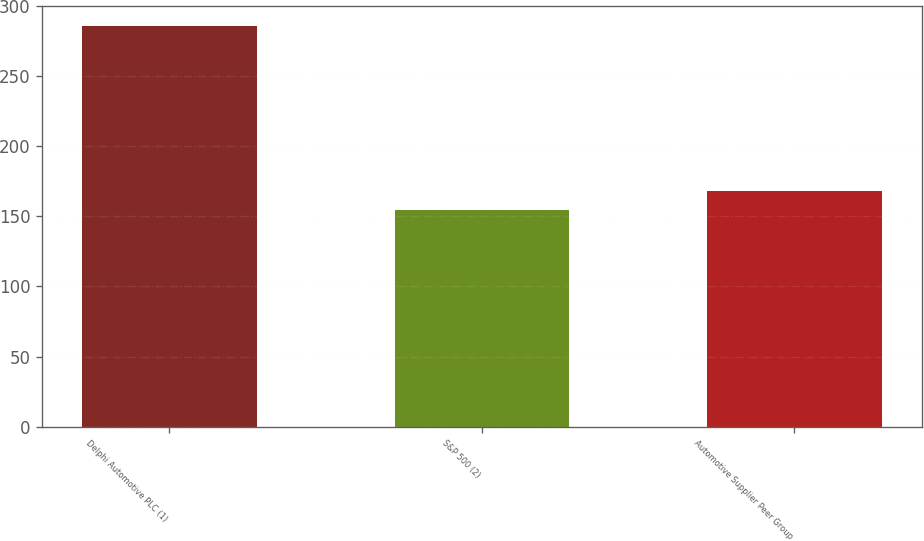<chart> <loc_0><loc_0><loc_500><loc_500><bar_chart><fcel>Delphi Automotive PLC (1)<fcel>S&P 500 (2)<fcel>Automotive Supplier Peer Group<nl><fcel>285.81<fcel>154.8<fcel>167.9<nl></chart> 